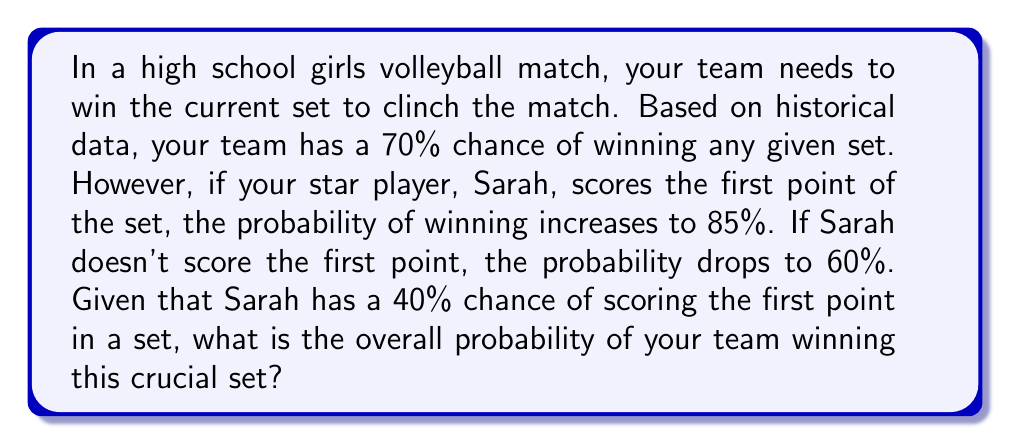Can you answer this question? Let's approach this step-by-step using conditional probability:

1) Define events:
   W: Winning the set
   S: Sarah scores the first point

2) Given probabilities:
   P(S) = 0.40
   P(W|S) = 0.85 (probability of winning given Sarah scores first)
   P(W|not S) = 0.60 (probability of winning given Sarah doesn't score first)

3) We need to find P(W) using the law of total probability:
   $$P(W) = P(W|S) \cdot P(S) + P(W|\text{not }S) \cdot P(\text{not }S)$$

4) Calculate P(not S):
   $$P(\text{not }S) = 1 - P(S) = 1 - 0.40 = 0.60$$

5) Substitute values into the formula:
   $$P(W) = 0.85 \cdot 0.40 + 0.60 \cdot 0.60$$

6) Calculate:
   $$P(W) = 0.34 + 0.36 = 0.70$$

Therefore, the overall probability of winning the set is 0.70 or 70%.
Answer: 0.70 